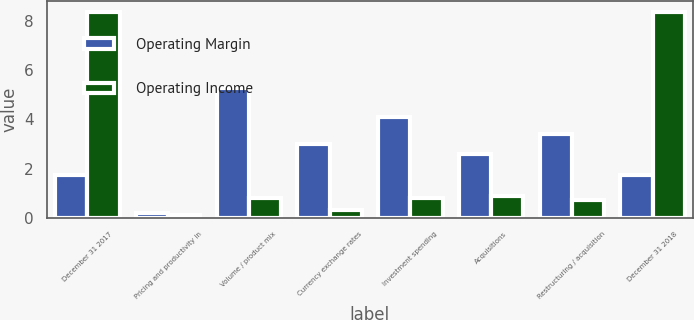Convert chart. <chart><loc_0><loc_0><loc_500><loc_500><stacked_bar_chart><ecel><fcel>December 31 2017<fcel>Pricing and productivity in<fcel>Volume / product mix<fcel>Currency exchange rates<fcel>Investment spending<fcel>Acquisitions<fcel>Restructuring / acquisition<fcel>December 31 2018<nl><fcel>Operating Margin<fcel>1.75<fcel>0.2<fcel>5.3<fcel>3<fcel>4.1<fcel>2.6<fcel>3.4<fcel>1.75<nl><fcel>Operating Income<fcel>8.4<fcel>0.1<fcel>0.8<fcel>0.3<fcel>0.8<fcel>0.9<fcel>0.7<fcel>8.4<nl></chart> 